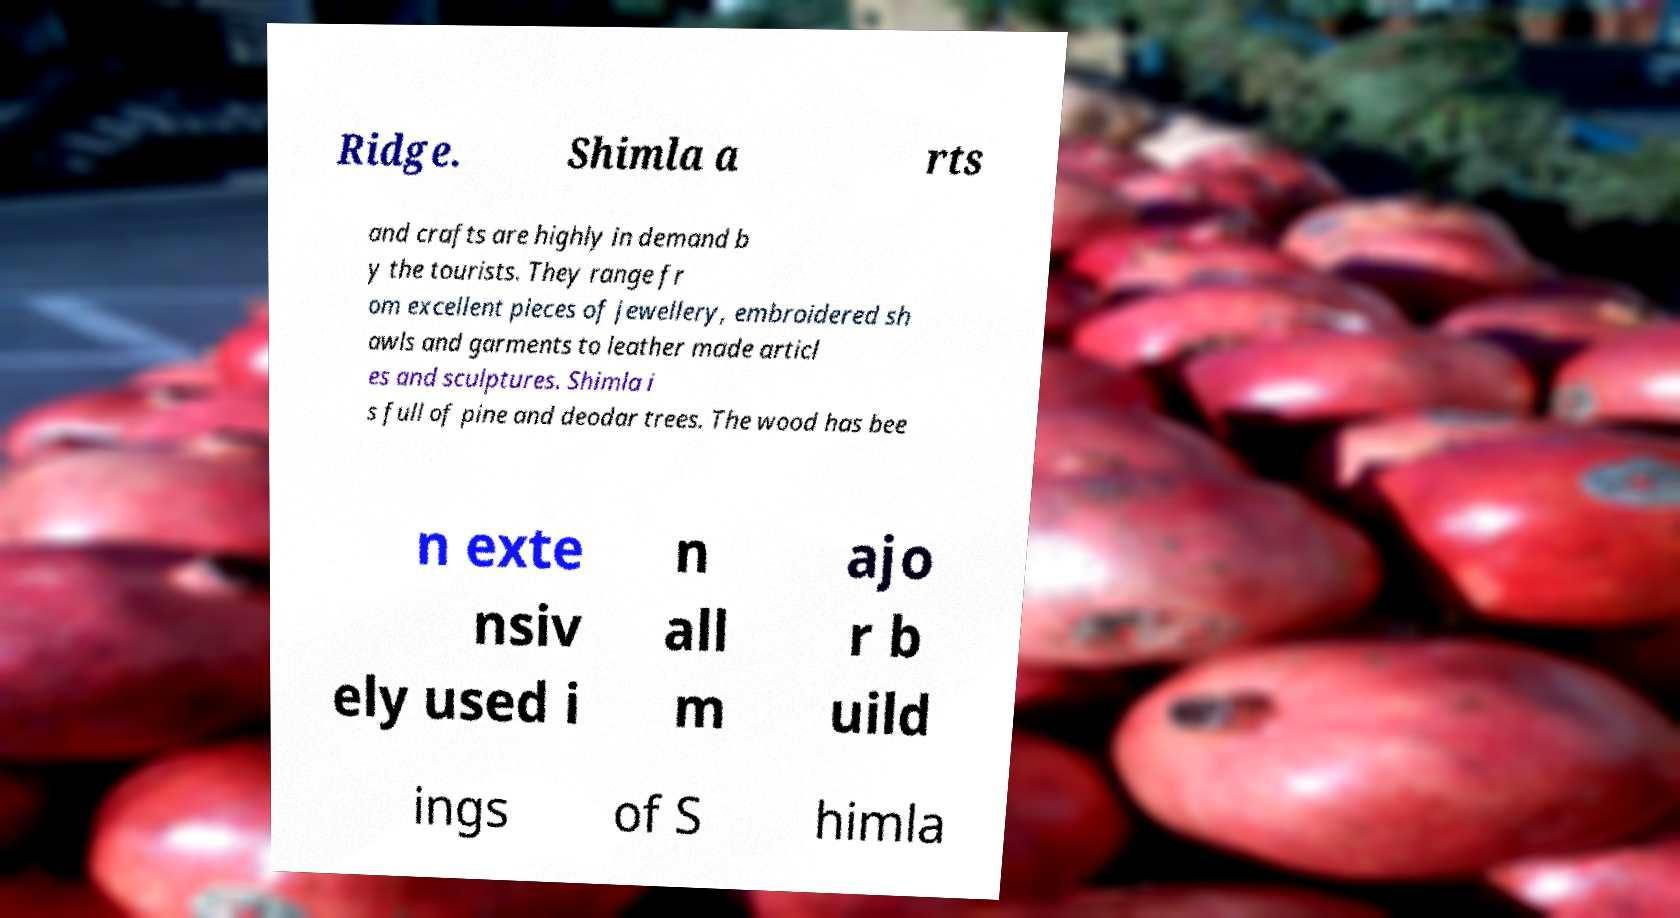What messages or text are displayed in this image? I need them in a readable, typed format. Ridge. Shimla a rts and crafts are highly in demand b y the tourists. They range fr om excellent pieces of jewellery, embroidered sh awls and garments to leather made articl es and sculptures. Shimla i s full of pine and deodar trees. The wood has bee n exte nsiv ely used i n all m ajo r b uild ings of S himla 